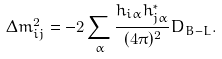<formula> <loc_0><loc_0><loc_500><loc_500>\Delta m ^ { 2 } _ { i j } = - 2 \sum _ { \alpha } \frac { h _ { i \alpha } h _ { j \alpha } ^ { * } } { ( 4 \pi ) ^ { 2 } } D _ { B - L } .</formula> 